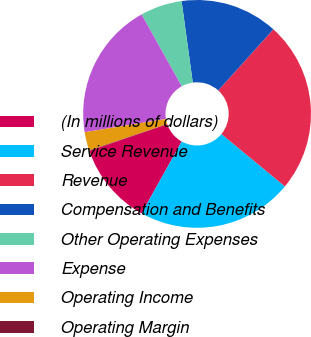<chart> <loc_0><loc_0><loc_500><loc_500><pie_chart><fcel>(In millions of dollars)<fcel>Service Revenue<fcel>Revenue<fcel>Compensation and Benefits<fcel>Other Operating Expenses<fcel>Expense<fcel>Operating Income<fcel>Operating Margin<nl><fcel>11.65%<fcel>22.1%<fcel>24.3%<fcel>13.85%<fcel>5.93%<fcel>19.47%<fcel>2.62%<fcel>0.07%<nl></chart> 